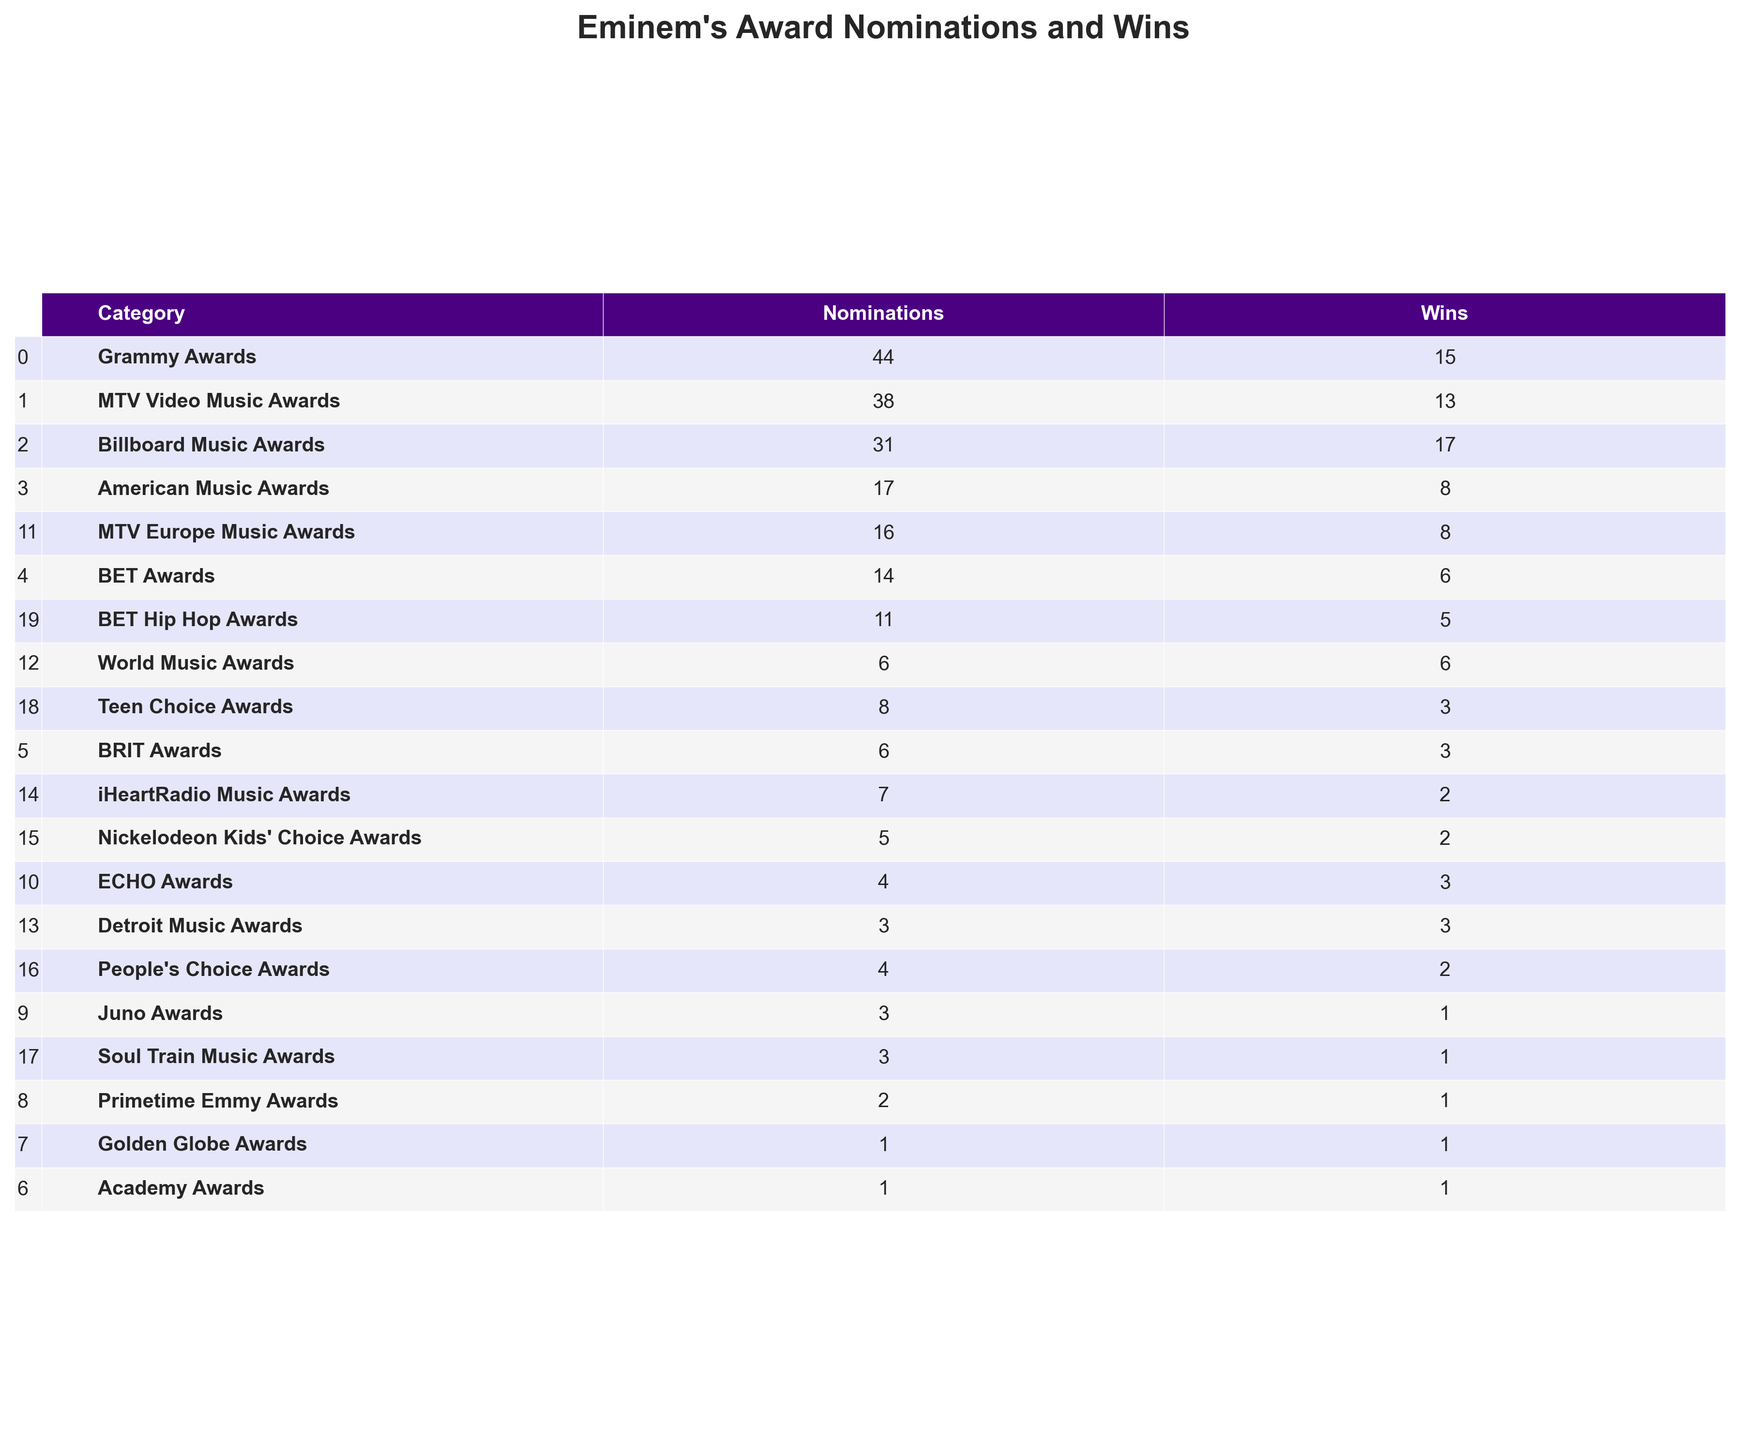What is the total number of Grammy Awards won by Eminem? The table indicates that Eminem won 15 Grammy Awards, as listed under the "Wins" column for the "Grammy Awards" category.
Answer: 15 How many more MTV Video Music Awards nominations does Eminem have compared to wins? Eminem has 38 nominations and 13 wins for MTV Video Music Awards. The difference is 38 - 13 = 25.
Answer: 25 Which award category has the highest number of wins for Eminem? By examining the "Wins" column, the "Billboard Music Awards" has the highest number of wins with 17.
Answer: Billboard Music Awards What is the total number of nominations Eminem has received across the BET Awards and the Goldman Globe Awards? Eminem received 14 nominations for the BET Awards and 1 nomination for the Golden Globe Awards. Summing these gives 14 + 1 = 15.
Answer: 15 True or False: Eminem has won more American Music Awards than BET Awards. Eminem won 8 American Music Awards and 6 BET Awards, which confirms that he has more American Music Awards wins.
Answer: True What is the average number of wins for the award categories in which Eminem has received nominations? Eminem has a total of 15 wins across 12 categories (excluding categories with zero nominations), so the average is 15 / 12 = 1.25 wins per category.
Answer: 1.25 Which two award categories have the same number of wins? The table shows that the "World Music Awards" and "BET Awards" both have 6 wins, making them equal in this regard.
Answer: World Music Awards and BET Awards If you only consider the Grammy and Billboard Music Awards, what is the ratio of Grammy wins to Billboard wins? Eminem has 15 Grammy wins and 17 Billboard wins. The ratio is 15:17, which simplifies to about 0.88.
Answer: 15:17 How many more Grammy nominations does Eminem have than Juno Awards nominations? The table shows Eminem has 44 Grammy nominations and 3 Juno Awards nominations. The difference is 44 - 3 = 41 more nominations.
Answer: 41 Which category has the least number of nominations for Eminem? By examining the table, the "Academy Awards" has the least number of nominations with only 1.
Answer: Academy Awards 